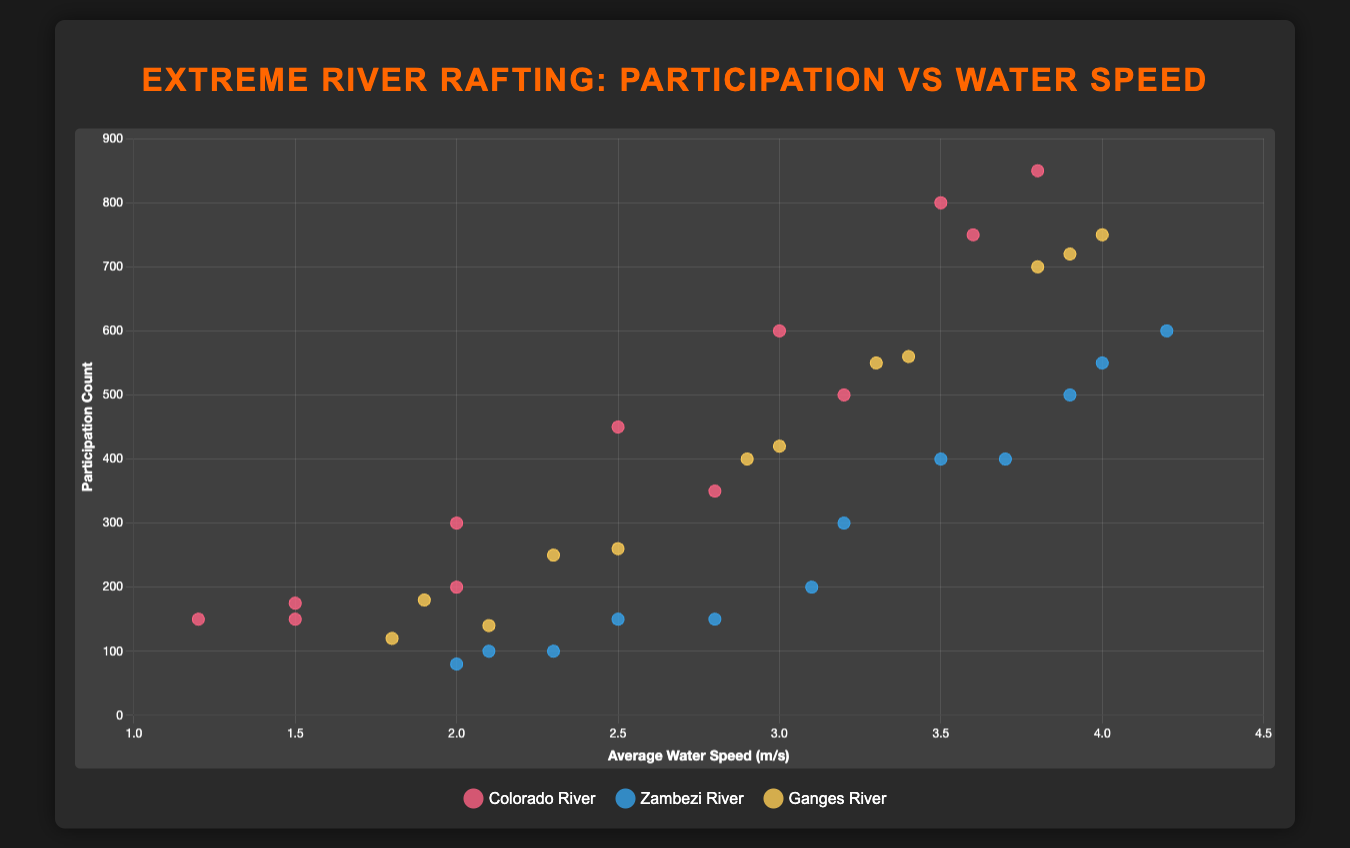What is the general trend observed between water speed and participation count for the Colorado River? Initially, from January to July, as the water speed increases, the participation count also increases, peaking in July. After July, both the water speed and the participation count start to decline
Answer: As water speed increases, participation count also increases until July, then both decline What is the highest participation count observed for the Zambezi River, and in which month does it occur? The highest participation count for the Zambezi River is in July with 600 participants, as observed from the peak point in the plot for the Zambezi River section
Answer: 600 in July On which river does the highest average water speed occur, and in which month? The highest average water speed occurs on the Zambezi River in July, with a speed of 4.2 m/s, as indicated by the point with the highest x-coordinate on the Zambezi River line
Answer: Zambezi River in July Comparing March across all rivers, which river has the highest participation count? In March, the participation counts for the Colorado River, Zambezi River, and Ganges River are 300, 150, and 260, respectively. Therefore, the Colorado River has the highest participation count
Answer: Colorado River What is the average water speed for the Colorado River during the peak participation count month? The peak participation count for the Colorado River is 850, which occurs in July. The water speed during this month is 3.8 m/s, as indicated by the corresponding point. Therefore, the average water speed in July is 3.8 m/s
Answer: 3.8 m/s How does the trend in participation count change after the peak month for the Ganges River? For the Ganges River, the peak participation count occurs in July with 750 participants. After July, both the water speed and participation count gradually decrease until the end of the year, as seen in the downward trend of the data points for the Ganges River line
Answer: Participation count decreases What's the total participation count for the Colorado River during the first half of the year (January to June)? The participation counts for the Colorado River from January to June are 150, 175, 300, 450, 600, and 800, respectively. Summing these values gives a total of (150 + 175 + 300 + 450 + 600 + 800) = 2475
Answer: 2475 If we compare the participation counts in August, which river experiences the highest number of participants, and what is the count? In August, the participation counts are 750 for the Colorado River, 550 for the Zambezi River, and 720 for the Ganges River. Thus, the Colorado River has the highest participation count at 750
Answer: Colorado River with 750 participants What is the participation count difference between the months of June and September for the Colorado River? For the Colorado River, the participation count in June is 800, and in September, it is 500. The difference is (800 - 500) = 300
Answer: 300 